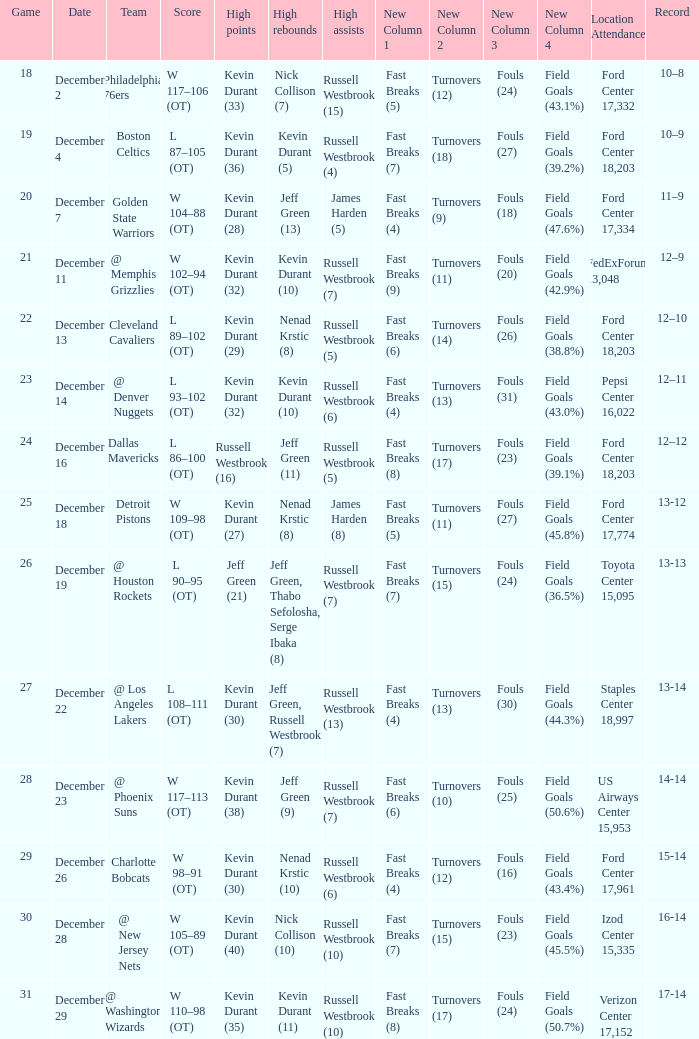Who has high points when toyota center 15,095 is location attendance? Jeff Green (21). 